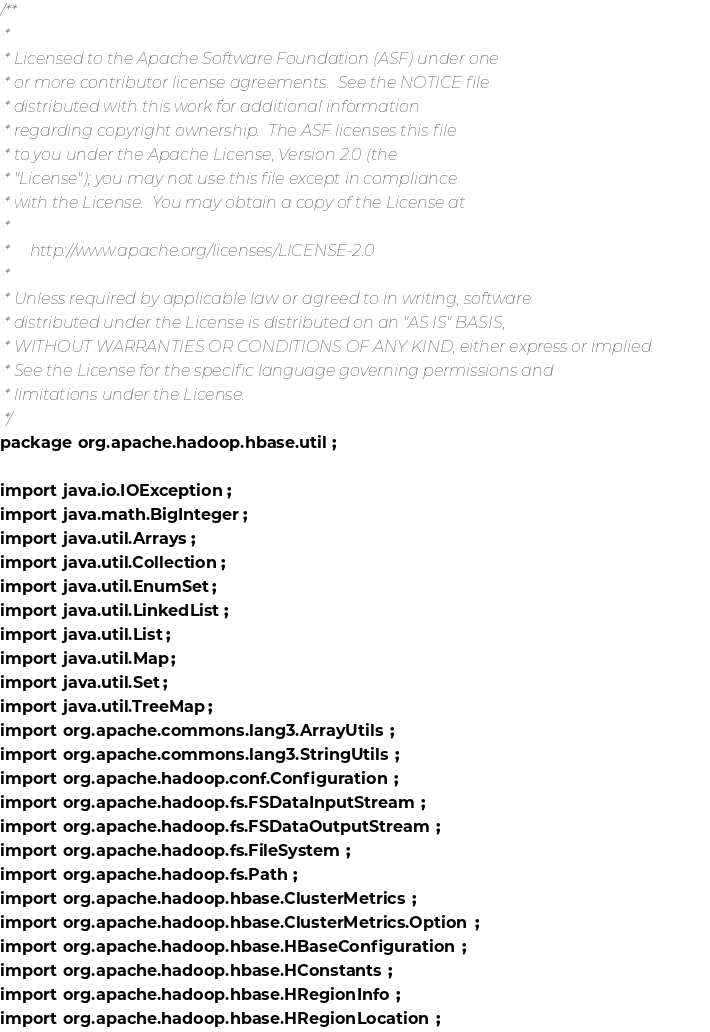<code> <loc_0><loc_0><loc_500><loc_500><_Java_>/**
 *
 * Licensed to the Apache Software Foundation (ASF) under one
 * or more contributor license agreements.  See the NOTICE file
 * distributed with this work for additional information
 * regarding copyright ownership.  The ASF licenses this file
 * to you under the Apache License, Version 2.0 (the
 * "License"); you may not use this file except in compliance
 * with the License.  You may obtain a copy of the License at
 *
 *     http://www.apache.org/licenses/LICENSE-2.0
 *
 * Unless required by applicable law or agreed to in writing, software
 * distributed under the License is distributed on an "AS IS" BASIS,
 * WITHOUT WARRANTIES OR CONDITIONS OF ANY KIND, either express or implied.
 * See the License for the specific language governing permissions and
 * limitations under the License.
 */
package org.apache.hadoop.hbase.util;

import java.io.IOException;
import java.math.BigInteger;
import java.util.Arrays;
import java.util.Collection;
import java.util.EnumSet;
import java.util.LinkedList;
import java.util.List;
import java.util.Map;
import java.util.Set;
import java.util.TreeMap;
import org.apache.commons.lang3.ArrayUtils;
import org.apache.commons.lang3.StringUtils;
import org.apache.hadoop.conf.Configuration;
import org.apache.hadoop.fs.FSDataInputStream;
import org.apache.hadoop.fs.FSDataOutputStream;
import org.apache.hadoop.fs.FileSystem;
import org.apache.hadoop.fs.Path;
import org.apache.hadoop.hbase.ClusterMetrics;
import org.apache.hadoop.hbase.ClusterMetrics.Option;
import org.apache.hadoop.hbase.HBaseConfiguration;
import org.apache.hadoop.hbase.HConstants;
import org.apache.hadoop.hbase.HRegionInfo;
import org.apache.hadoop.hbase.HRegionLocation;</code> 